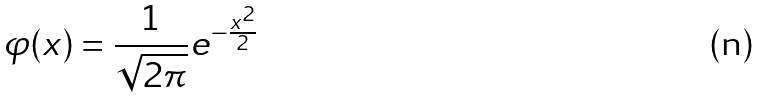Convert formula to latex. <formula><loc_0><loc_0><loc_500><loc_500>\varphi ( x ) = { \frac { 1 } { \sqrt { 2 \pi } } } e ^ { - { \frac { x ^ { 2 } } { 2 } } }</formula> 